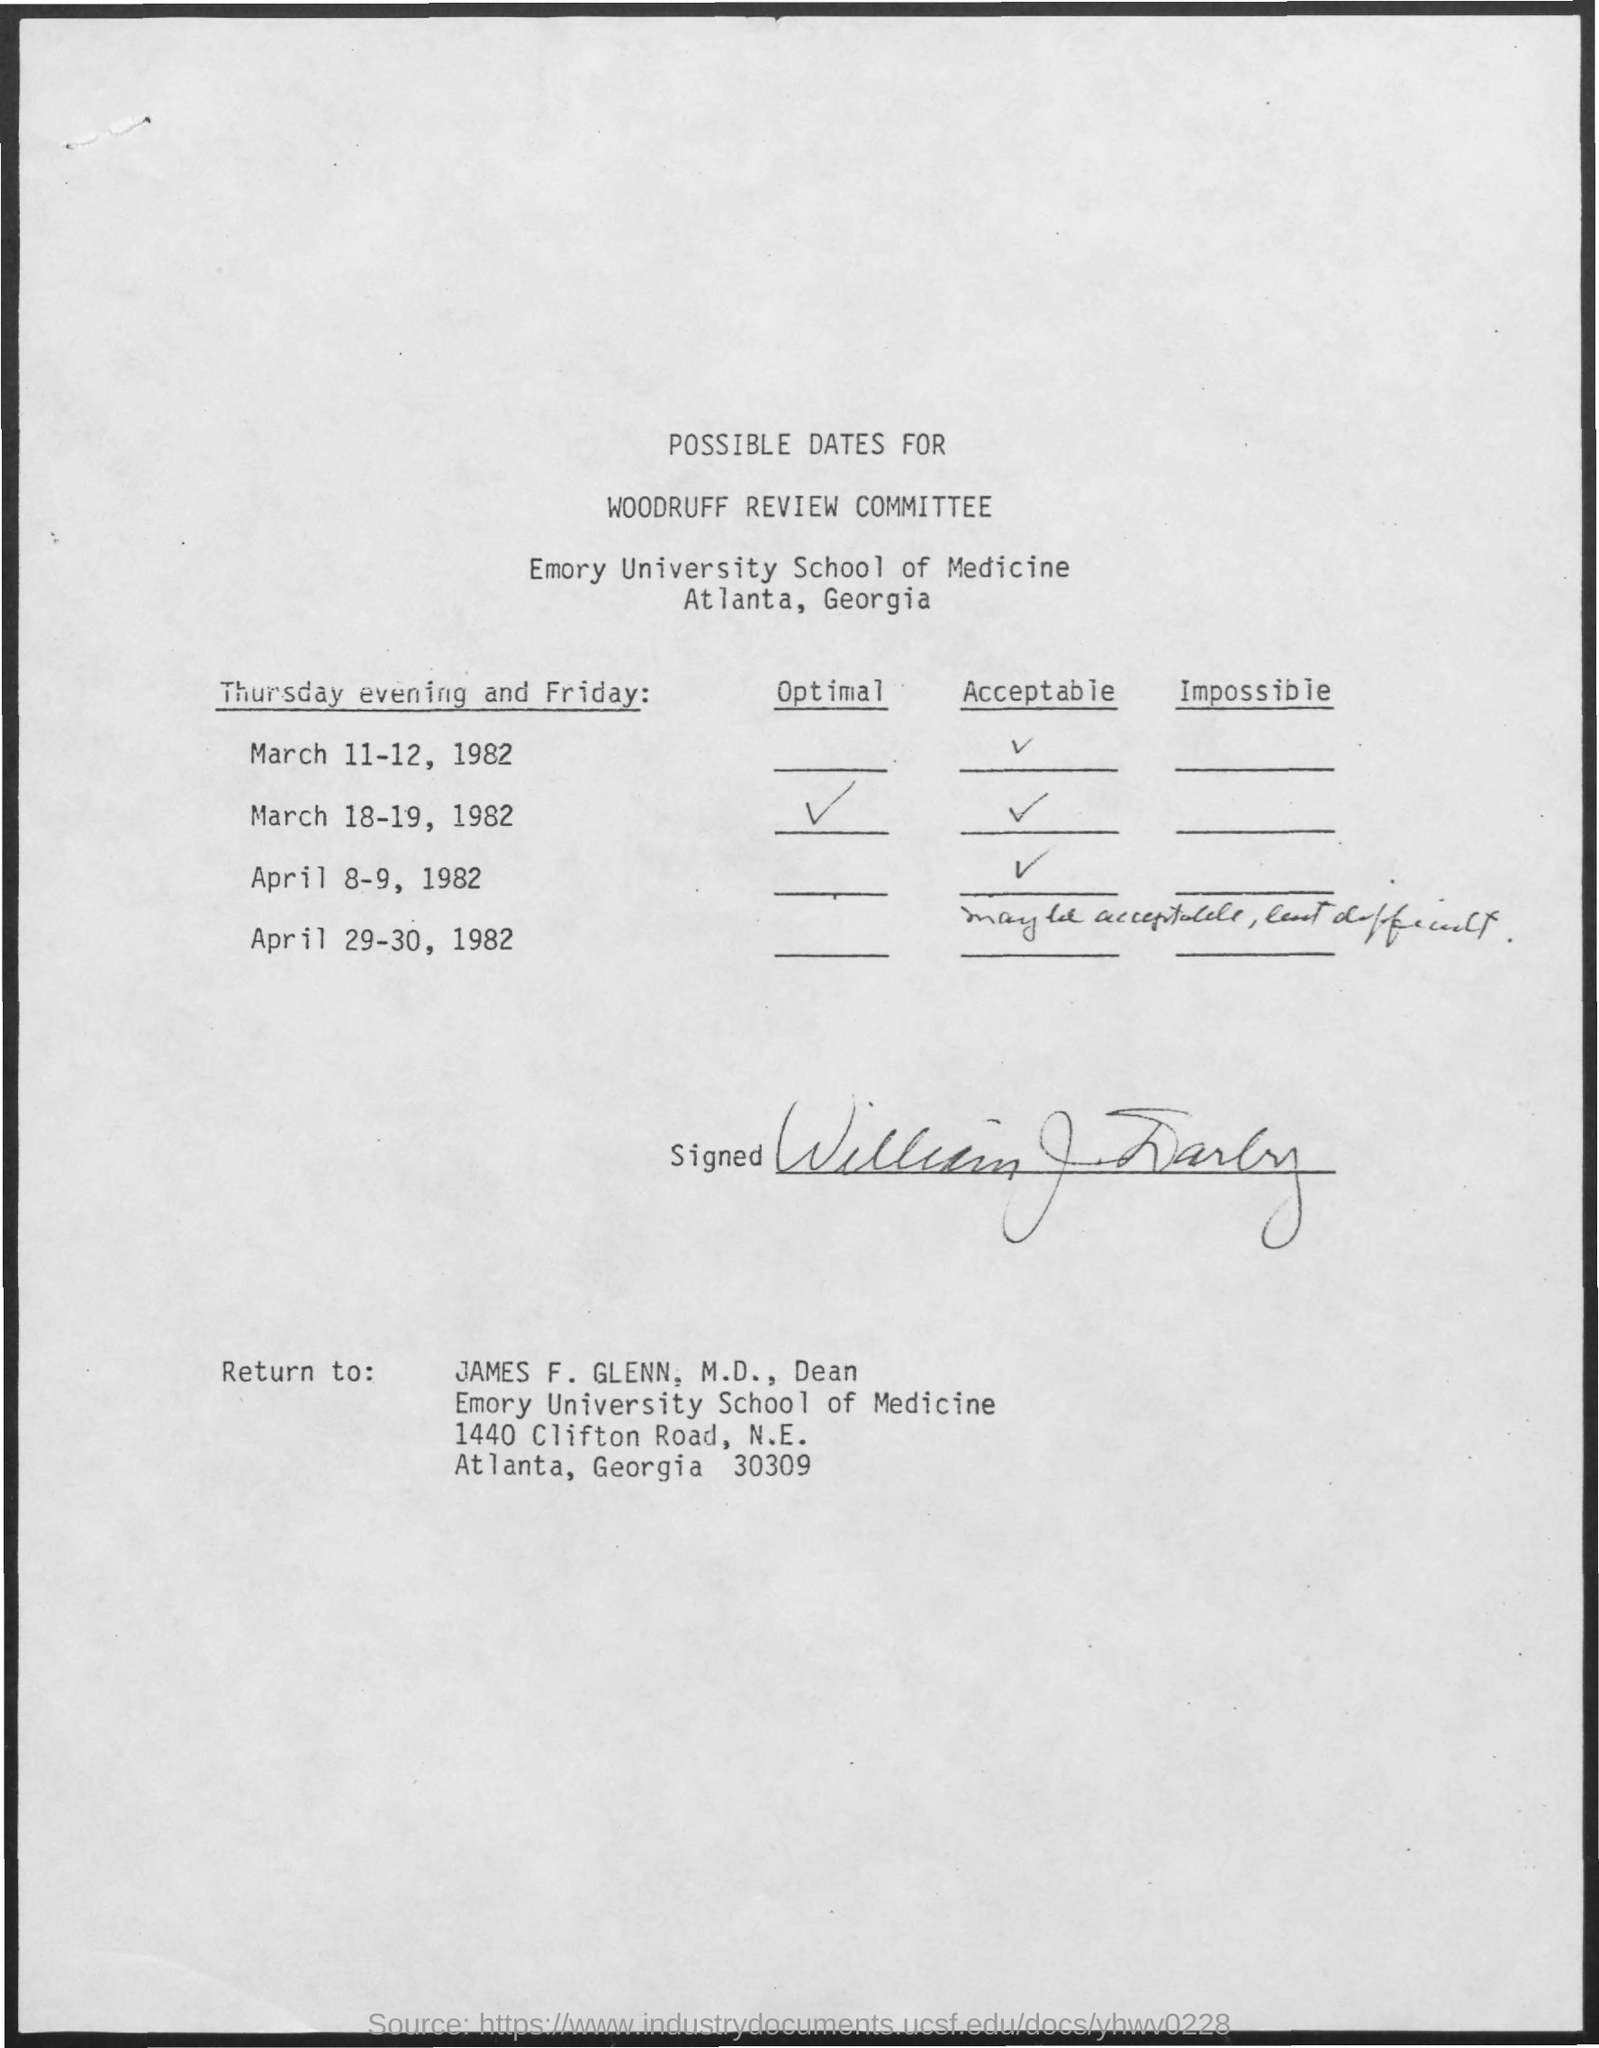Specify some key components in this picture. The date of March 18-19, 1982, is optimal. Emory University is mentioned. The form should be returned to James F. Glenn. The document is about the Woodruff Review Committee and its possible dates. 